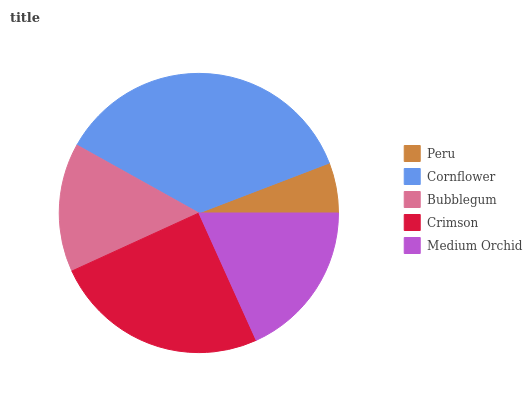Is Peru the minimum?
Answer yes or no. Yes. Is Cornflower the maximum?
Answer yes or no. Yes. Is Bubblegum the minimum?
Answer yes or no. No. Is Bubblegum the maximum?
Answer yes or no. No. Is Cornflower greater than Bubblegum?
Answer yes or no. Yes. Is Bubblegum less than Cornflower?
Answer yes or no. Yes. Is Bubblegum greater than Cornflower?
Answer yes or no. No. Is Cornflower less than Bubblegum?
Answer yes or no. No. Is Medium Orchid the high median?
Answer yes or no. Yes. Is Medium Orchid the low median?
Answer yes or no. Yes. Is Bubblegum the high median?
Answer yes or no. No. Is Crimson the low median?
Answer yes or no. No. 